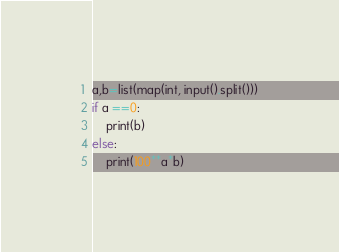<code> <loc_0><loc_0><loc_500><loc_500><_Python_>a,b=list(map(int, input().split()))
if a ==0:
    print(b)
else:
    print(100**a*b)</code> 